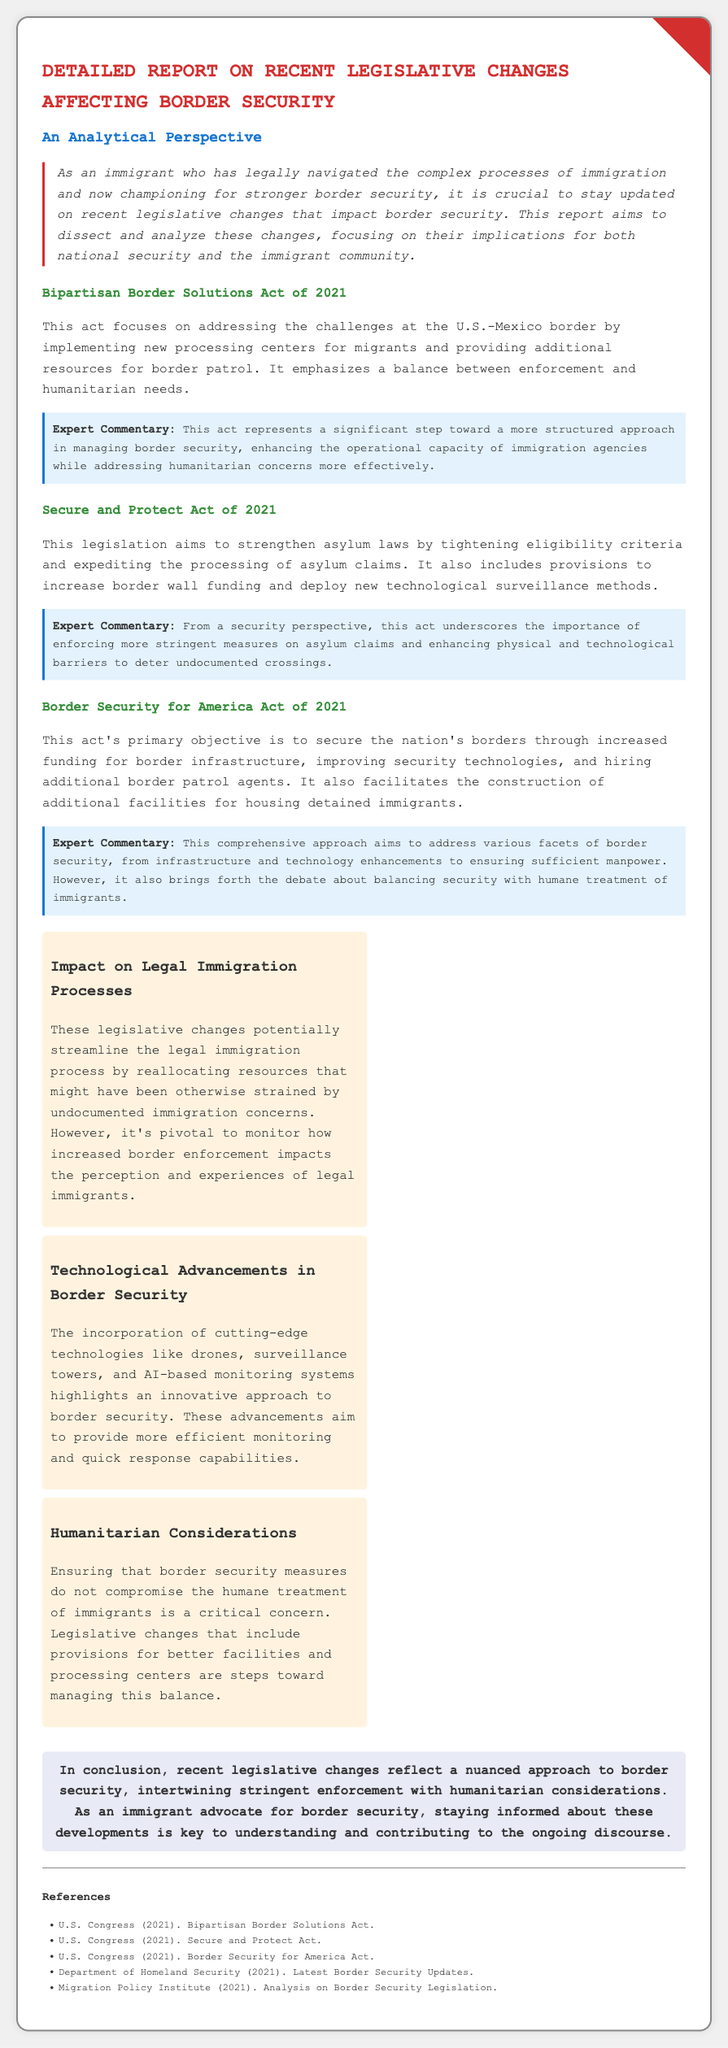what is the title of the report? The title of the report is stated in the header section of the document.
Answer: Detailed Report on Recent Legislative Changes Affecting Border Security what year was the Bipartisan Border Solutions Act introduced? The year this act was introduced can be found in the section title of the act.
Answer: 2021 what is one key aim of the Secure and Protect Act? The key aim is mentioned in the summary of the act, detailing its purpose.
Answer: Strengthen asylum laws what does the Border Security for America Act emphasize? The emphasis of this act is described in its primary objective section.
Answer: Securing the nation's borders how many policy analysis items are presented in the document? The document contains a specific number of policy analysis items listed.
Answer: Three what is a significant concern mentioned related to border security? The concern is discussed within the humanitarian considerations section of the policy analysis.
Answer: Humane treatment of immigrants which organization's 2021 updates are referenced in the document? The organization providing updates is mentioned in the references section at the end of the document.
Answer: Department of Homeland Security who authored the legislation referenced in the document? The authoring body of the legislation can be discerned from the references provided.
Answer: U.S. Congress 